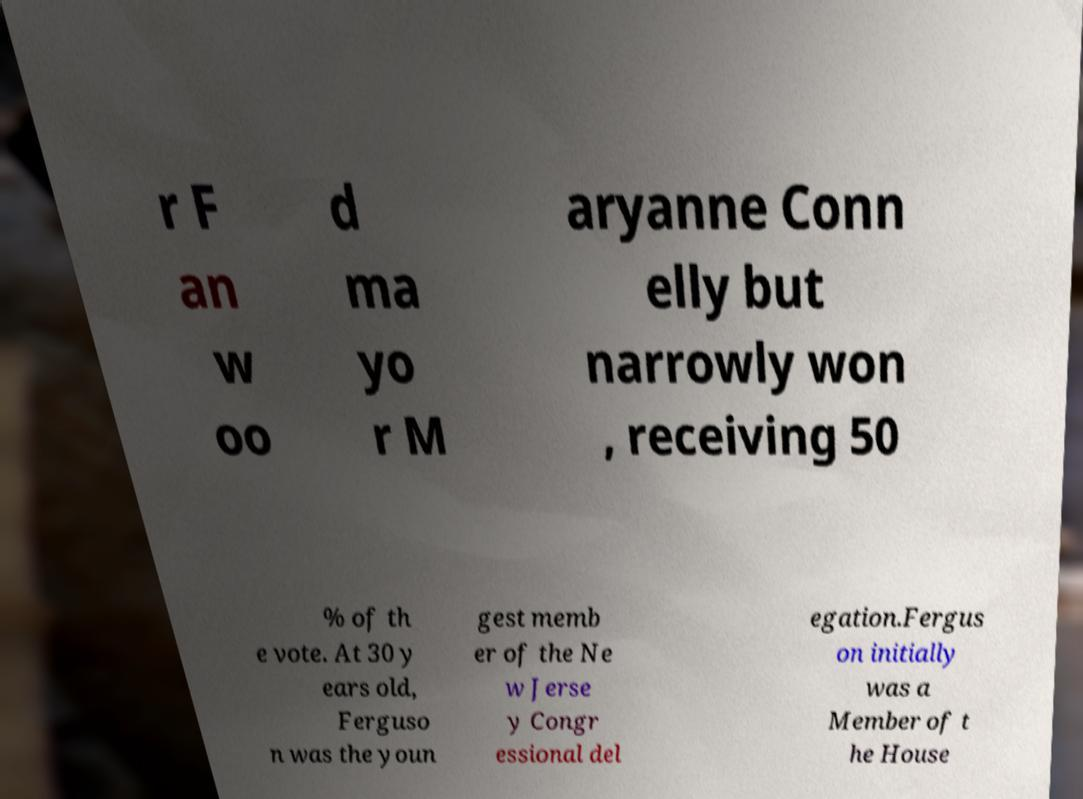There's text embedded in this image that I need extracted. Can you transcribe it verbatim? r F an w oo d ma yo r M aryanne Conn elly but narrowly won , receiving 50 % of th e vote. At 30 y ears old, Ferguso n was the youn gest memb er of the Ne w Jerse y Congr essional del egation.Fergus on initially was a Member of t he House 